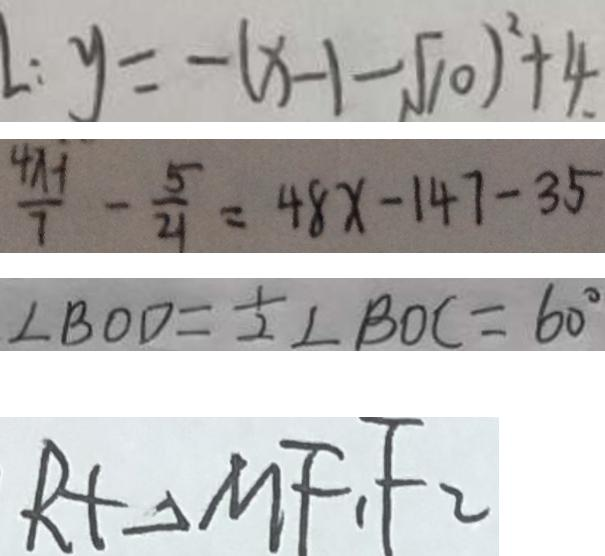<formula> <loc_0><loc_0><loc_500><loc_500>: y = - ( x - 1 - \sqrt { 1 0 } ) ^ { 2 } + 4 . 
 \frac { 4 x - 1 } { 7 } - \frac { 5 } { 2 1 } = 4 8 x - 1 4 7 - 3 5 
 \angle B O D = \frac { 1 } { 2 } \angle B O C = 6 0 ^ { \circ } 
 R t \Delta M F _ { 1 } F _ { 2 }</formula> 